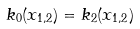<formula> <loc_0><loc_0><loc_500><loc_500>k _ { 0 } ( x _ { 1 , 2 } ) = k _ { 2 } ( x _ { 1 , 2 } )</formula> 